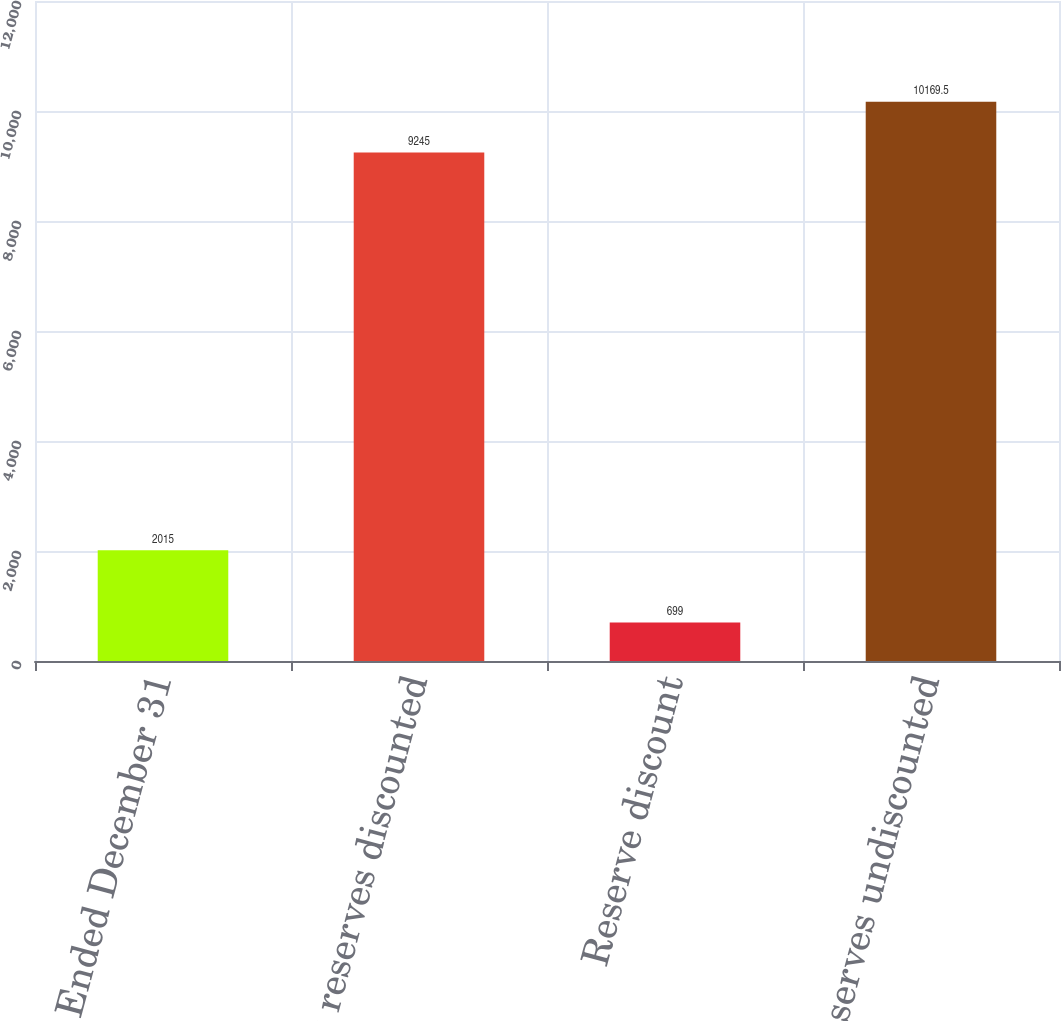<chart> <loc_0><loc_0><loc_500><loc_500><bar_chart><fcel>Year Ended December 31<fcel>Net reserves discounted<fcel>Reserve discount<fcel>Net Reserves undiscounted<nl><fcel>2015<fcel>9245<fcel>699<fcel>10169.5<nl></chart> 